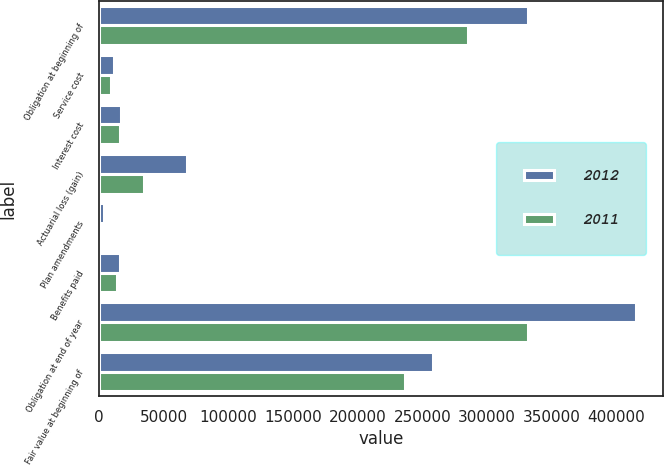<chart> <loc_0><loc_0><loc_500><loc_500><stacked_bar_chart><ecel><fcel>Obligation at beginning of<fcel>Service cost<fcel>Interest cost<fcel>Actuarial loss (gain)<fcel>Plan amendments<fcel>Benefits paid<fcel>Obligation at end of year<fcel>Fair value at beginning of<nl><fcel>2012<fcel>331609<fcel>11215<fcel>16796<fcel>67949<fcel>3452<fcel>16100<fcel>414921<fcel>258067<nl><fcel>2011<fcel>285560<fcel>9277<fcel>16106<fcel>34515<fcel>0<fcel>13849<fcel>331609<fcel>236893<nl></chart> 